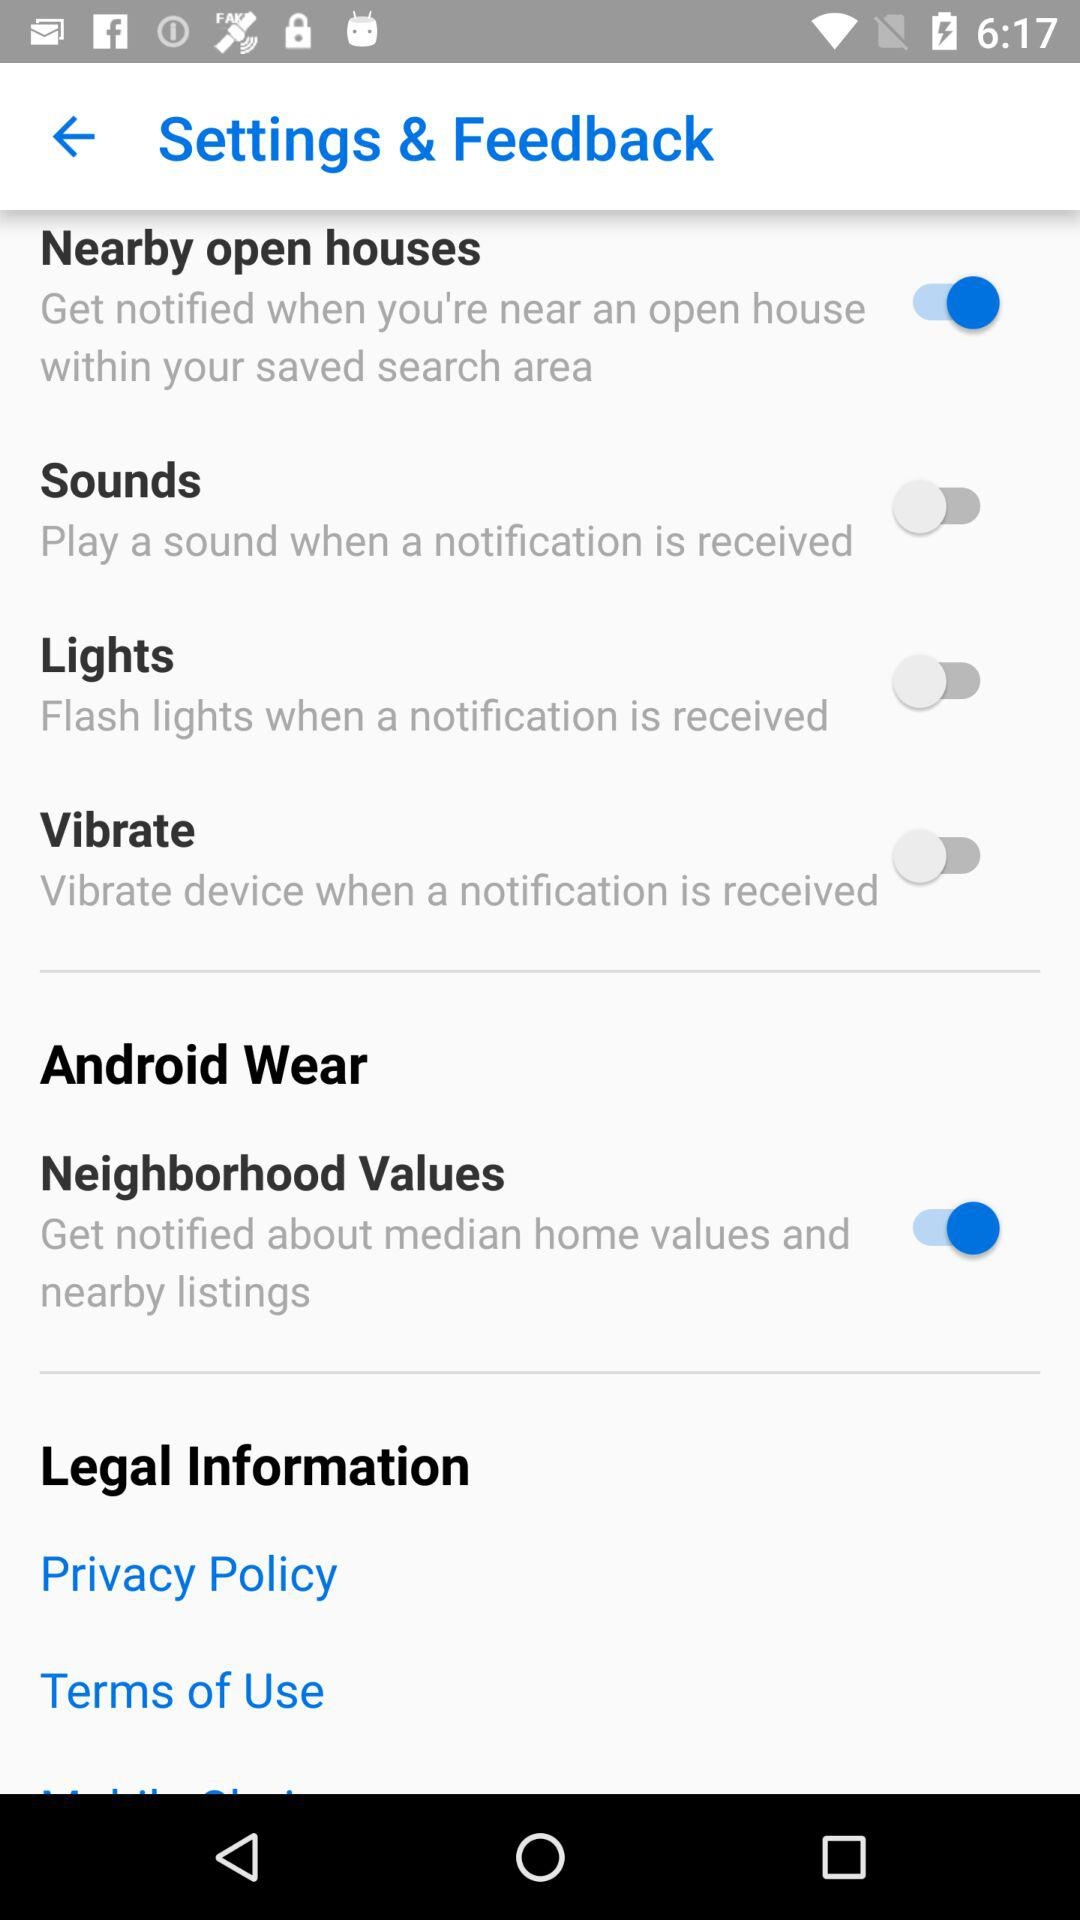What is the status of the "Lights"? The status is "off". 